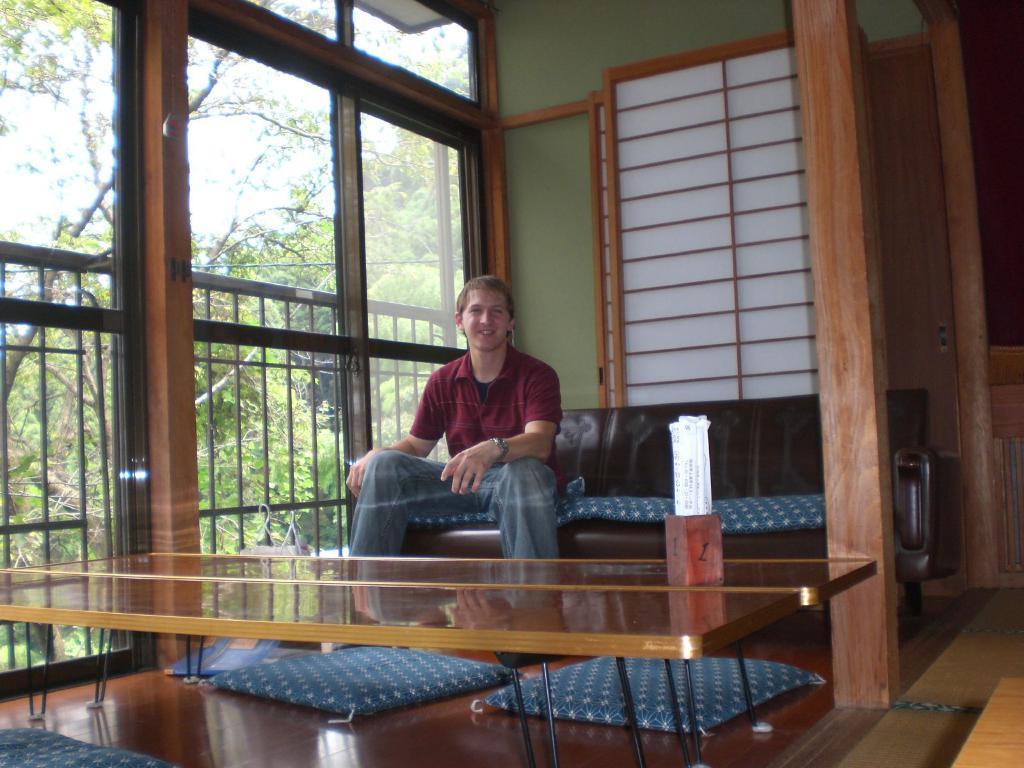Can you describe this image briefly? There is a man in the room sitting on the sofa in front of a table. There is a tin on the table in which some papers are placed. In the background, we can observe railing and trees here. 